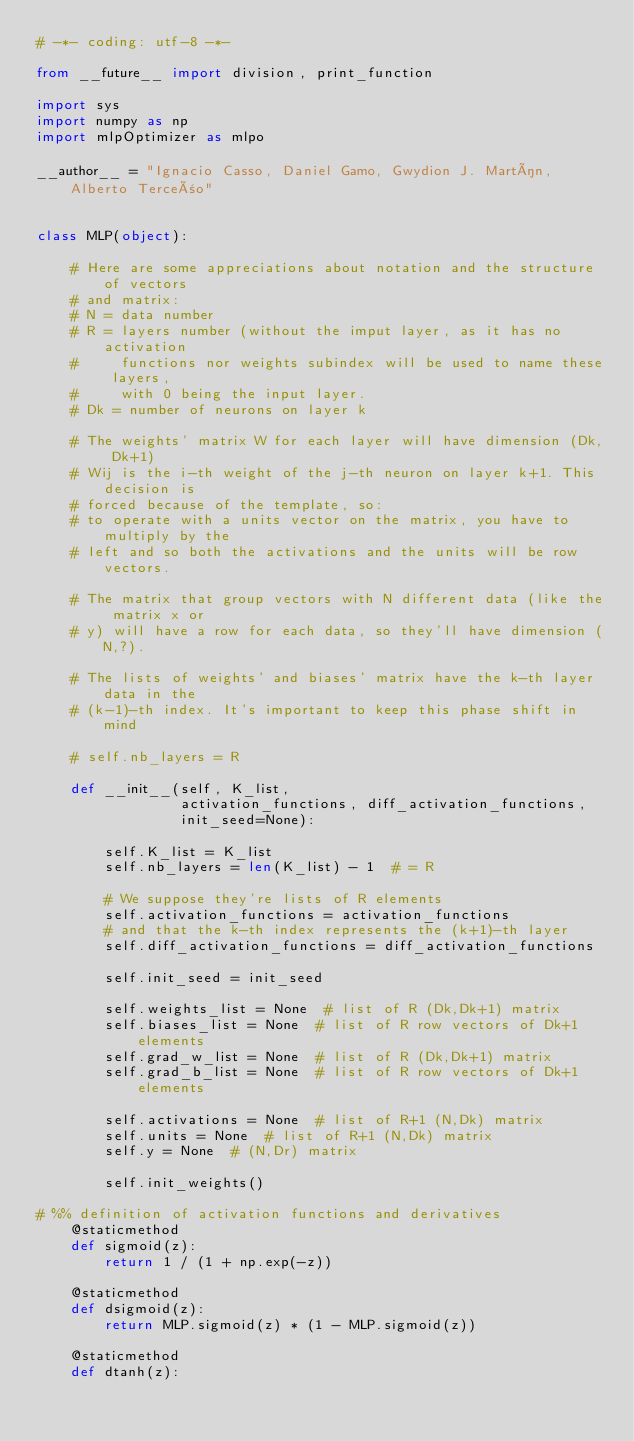<code> <loc_0><loc_0><loc_500><loc_500><_Python_># -*- coding: utf-8 -*-

from __future__ import division, print_function

import sys
import numpy as np
import mlpOptimizer as mlpo

__author__ = "Ignacio Casso, Daniel Gamo, Gwydion J. Martín, Alberto Terceño"


class MLP(object):

    # Here are some appreciations about notation and the structure of vectors
    # and matrix:
    # N = data number
    # R = layers number (without the imput layer, as it has no activation
    #     functions nor weights subindex will be used to name these layers,
    #     with 0 being the input layer.
    # Dk = number of neurons on layer k

    # The weights' matrix W for each layer will have dimension (Dk, Dk+1)
    # Wij is the i-th weight of the j-th neuron on layer k+1. This decision is
    # forced because of the template, so:
    # to operate with a units vector on the matrix, you have to multiply by the
    # left and so both the activations and the units will be row vectors.

    # The matrix that group vectors with N different data (like the matrix x or
    # y) will have a row for each data, so they'll have dimension (N,?).

    # The lists of weights' and biases' matrix have the k-th layer data in the
    # (k-1)-th index. It's important to keep this phase shift in mind

    # self.nb_layers = R

    def __init__(self, K_list,
                 activation_functions, diff_activation_functions,
                 init_seed=None):

        self.K_list = K_list
        self.nb_layers = len(K_list) - 1  # = R

        # We suppose they're lists of R elements
        self.activation_functions = activation_functions
        # and that the k-th index represents the (k+1)-th layer
        self.diff_activation_functions = diff_activation_functions

        self.init_seed = init_seed

        self.weights_list = None  # list of R (Dk,Dk+1) matrix
        self.biases_list = None  # list of R row vectors of Dk+1 elements
        self.grad_w_list = None  # list of R (Dk,Dk+1) matrix
        self.grad_b_list = None  # list of R row vectors of Dk+1 elements

        self.activations = None  # list of R+1 (N,Dk) matrix
        self.units = None  # list of R+1 (N,Dk) matrix
        self.y = None  # (N,Dr) matrix

        self.init_weights()

# %% definition of activation functions and derivatives
    @staticmethod
    def sigmoid(z):
        return 1 / (1 + np.exp(-z))

    @staticmethod
    def dsigmoid(z):
        return MLP.sigmoid(z) * (1 - MLP.sigmoid(z))

    @staticmethod
    def dtanh(z):</code> 